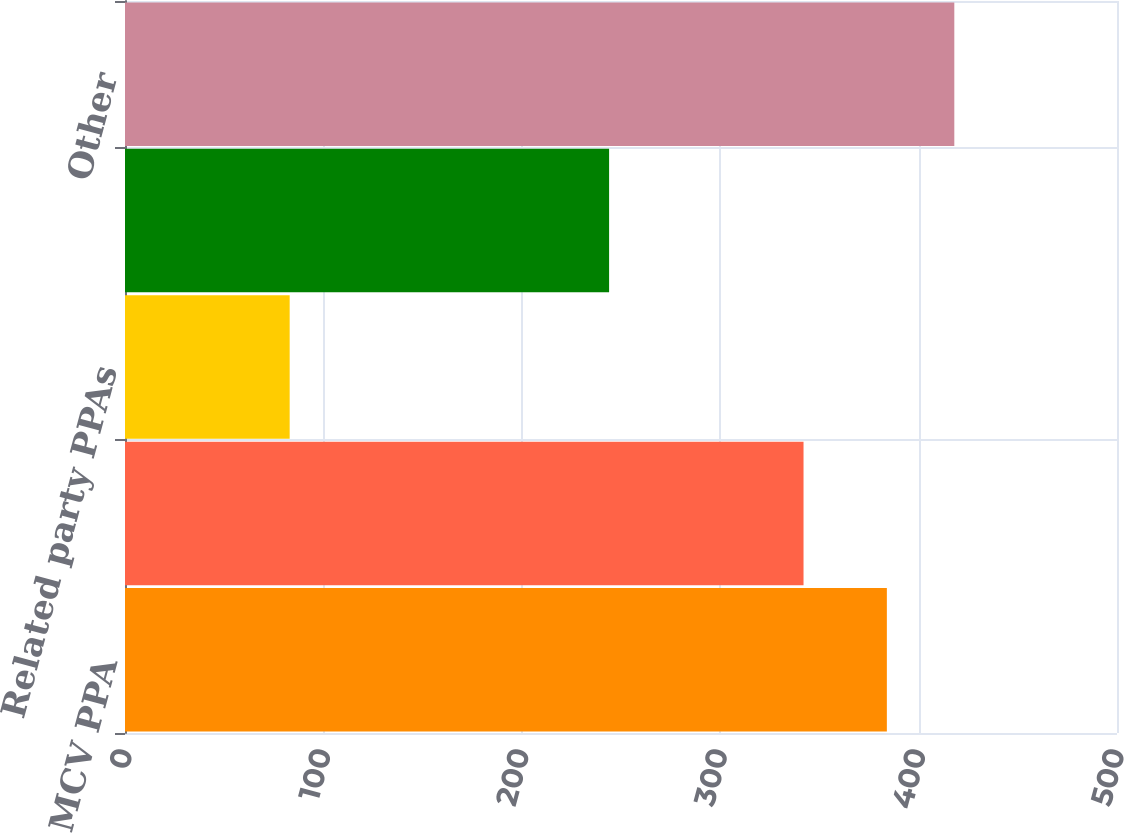<chart> <loc_0><loc_0><loc_500><loc_500><bar_chart><fcel>MCV PPA<fcel>Palisades PPA<fcel>Related party PPAs<fcel>Other PPAs<fcel>Other<nl><fcel>384<fcel>342<fcel>83<fcel>244<fcel>418<nl></chart> 